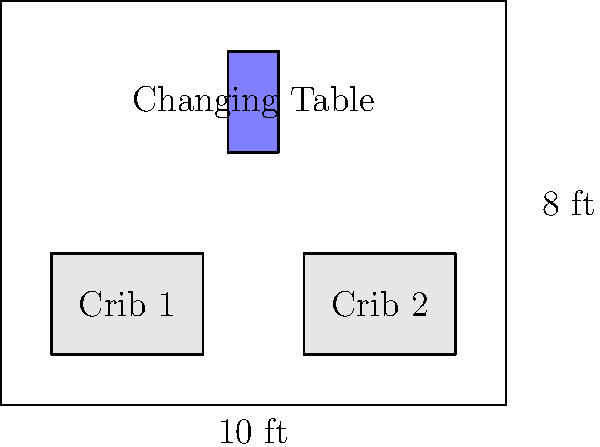In a rectangular nursery measuring 10 feet by 8 feet, you need to arrange two cribs and a changing table. The cribs are identical, measuring 3 feet by 2 feet each, and the changing table is 1 foot by 2 feet. What is the maximum distance possible between the two cribs while ensuring all furniture pieces are at least 1 foot away from the walls and each other? Let's approach this step-by-step:

1) First, we need to account for the minimum 1-foot clearance from the walls. This reduces our usable space to 8 feet by 6 feet.

2) The two cribs together occupy 6 feet in length (3 feet each). The changing table occupies 1 foot in length.

3) We need to ensure at least 1 foot between each piece of furniture. This accounts for 2 more feet.

4) So far, we've accounted for: 6 (cribs) + 1 (changing table) + 2 (spaces between furniture) = 9 feet

5) The total available length is 8 feet (10 feet - 2 feet for wall clearance).

6) The remaining space that can be used to maximize the distance between cribs is:
   8 feet - 9 feet = -1 foot

7) This negative value indicates that we can't fit all pieces with the given constraints while maintaining the 1-foot clearance everywhere.

8) To find the maximum possible distance, we need to reduce the clearance between the cribs and other elements.

9) If we place the cribs at opposite ends of the 8-foot usable length, and put the changing table in between, we get:
   3 (crib) + x (space) + 1 (changing table) + x (space) + 3 (crib) = 8
   where x is the space between a crib and the changing table.

10) Solving this equation:
    6 + 1 + 2x = 8
    2x = 1
    x = 0.5 feet or 6 inches

Therefore, the maximum distance between the cribs is the length of the room minus the length of both cribs:
8 - (3 + 3) = 2 feet
Answer: 2 feet 